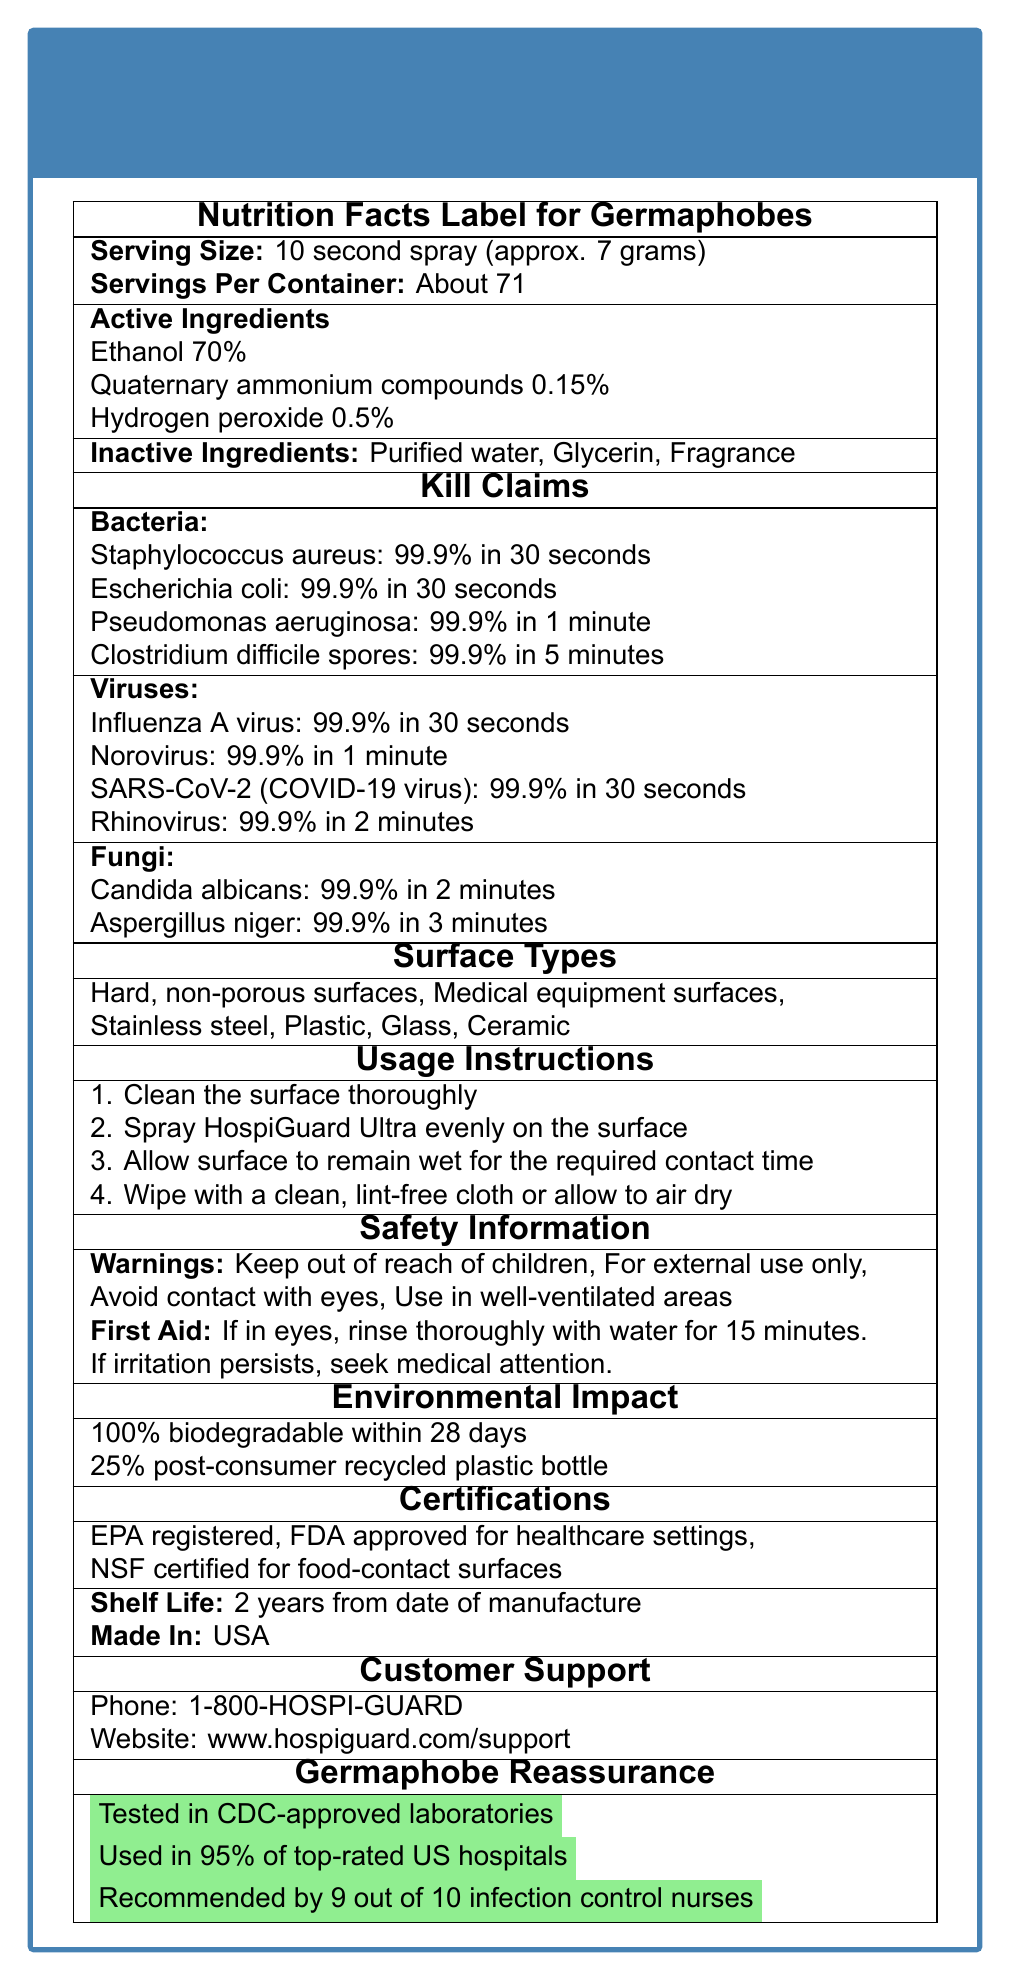What is the main active ingredient in the HospiGuard Ultra Disinfectant Spray? The document states that the active ingredients include "Ethanol 70%", which is listed first and in the highest concentration.
Answer: Ethanol Which bacteria are killed by the HospiGuard Ultra Disinfectant Spray within 30 seconds? According to the kill claims section, Staphylococcus aureus and Escherichia coli are killed 99.9% in 30 seconds.
Answer: Staphylococcus aureus and Escherichia coli What should you do if the HospiGuard Ultra Disinfectant Spray gets into your eyes? The safety information section under first aid instructions states this remediation for eye contact.
Answer: Rinse thoroughly with water for 15 minutes. If irritation persists, seek medical attention. How long is the shelf life of the HospiGuard Ultra Disinfectant Spray? The shelf life information is clearly listed in the document.
Answer: 2 years from the date of manufacture Which types of surfaces can the HospiGuard Ultra Disinfectant Spray be used on? The document lists these types of surfaces under the surface types section.
Answer: Hard, non-porous surfaces, Medical equipment surfaces, Stainless steel, Plastic, Glass, Ceramic How quickly does the disinfectant work on Influenza A virus? A. 30 seconds B. 1 minute C. 2 minutes D. 5 minutes The kill claims section specifies that Influenza A virus is killed 99.9% in 30 seconds.
Answer: A. 30 seconds Which certification indicates that the product is safe for use on food-contact surfaces? I. EPA registered II. FDA approved for healthcare settings III. NSF certified for food-contact surfaces The document shows "NSF certified for food-contact surfaces" under the certifications section.
Answer: III. NSF certified for food-contact surfaces Should this product be kept away from children? The safety information section under warnings states "Keep out of reach of children".
Answer: Yes Summarize the document. This summary covers the main aspects including the product's ingredients, effectiveness, safety, environmental impact, certifications, and usage instructions as detailed in the document.
Answer: The HospiGuard Ultra Disinfectant Spray is a hospital-grade disinfectant designed for various hard, non-porous surfaces. It contains 70% ethanol as its main active ingredient and effectively kills a wide range of bacteria, viruses, and fungi within specified timeframes. The product is safe for use in healthcare settings, is environmentally friendly, and has been tested and recommended by infection control nurses. Usage instructions, safety information, and customer support details are also provided. Does the document specify the country of origin for the HospiGuard Ultra Disinfectant Spray? The document clearly states that the product is made in the USA.
Answer: Yes What other scented options are available for HospiGuard Ultra Disinfectant Spray? The document mentions "Fragrance" as an inactive ingredient but does not provide details on different scented options.
Answer: Not enough information Is the HospiGuard Ultra Disinfectant Spray recommended by infection control nurses? The germaphobe reassurance section indicates that the product is recommended by 9 out of 10 infection control nurses.
Answer: Yes 